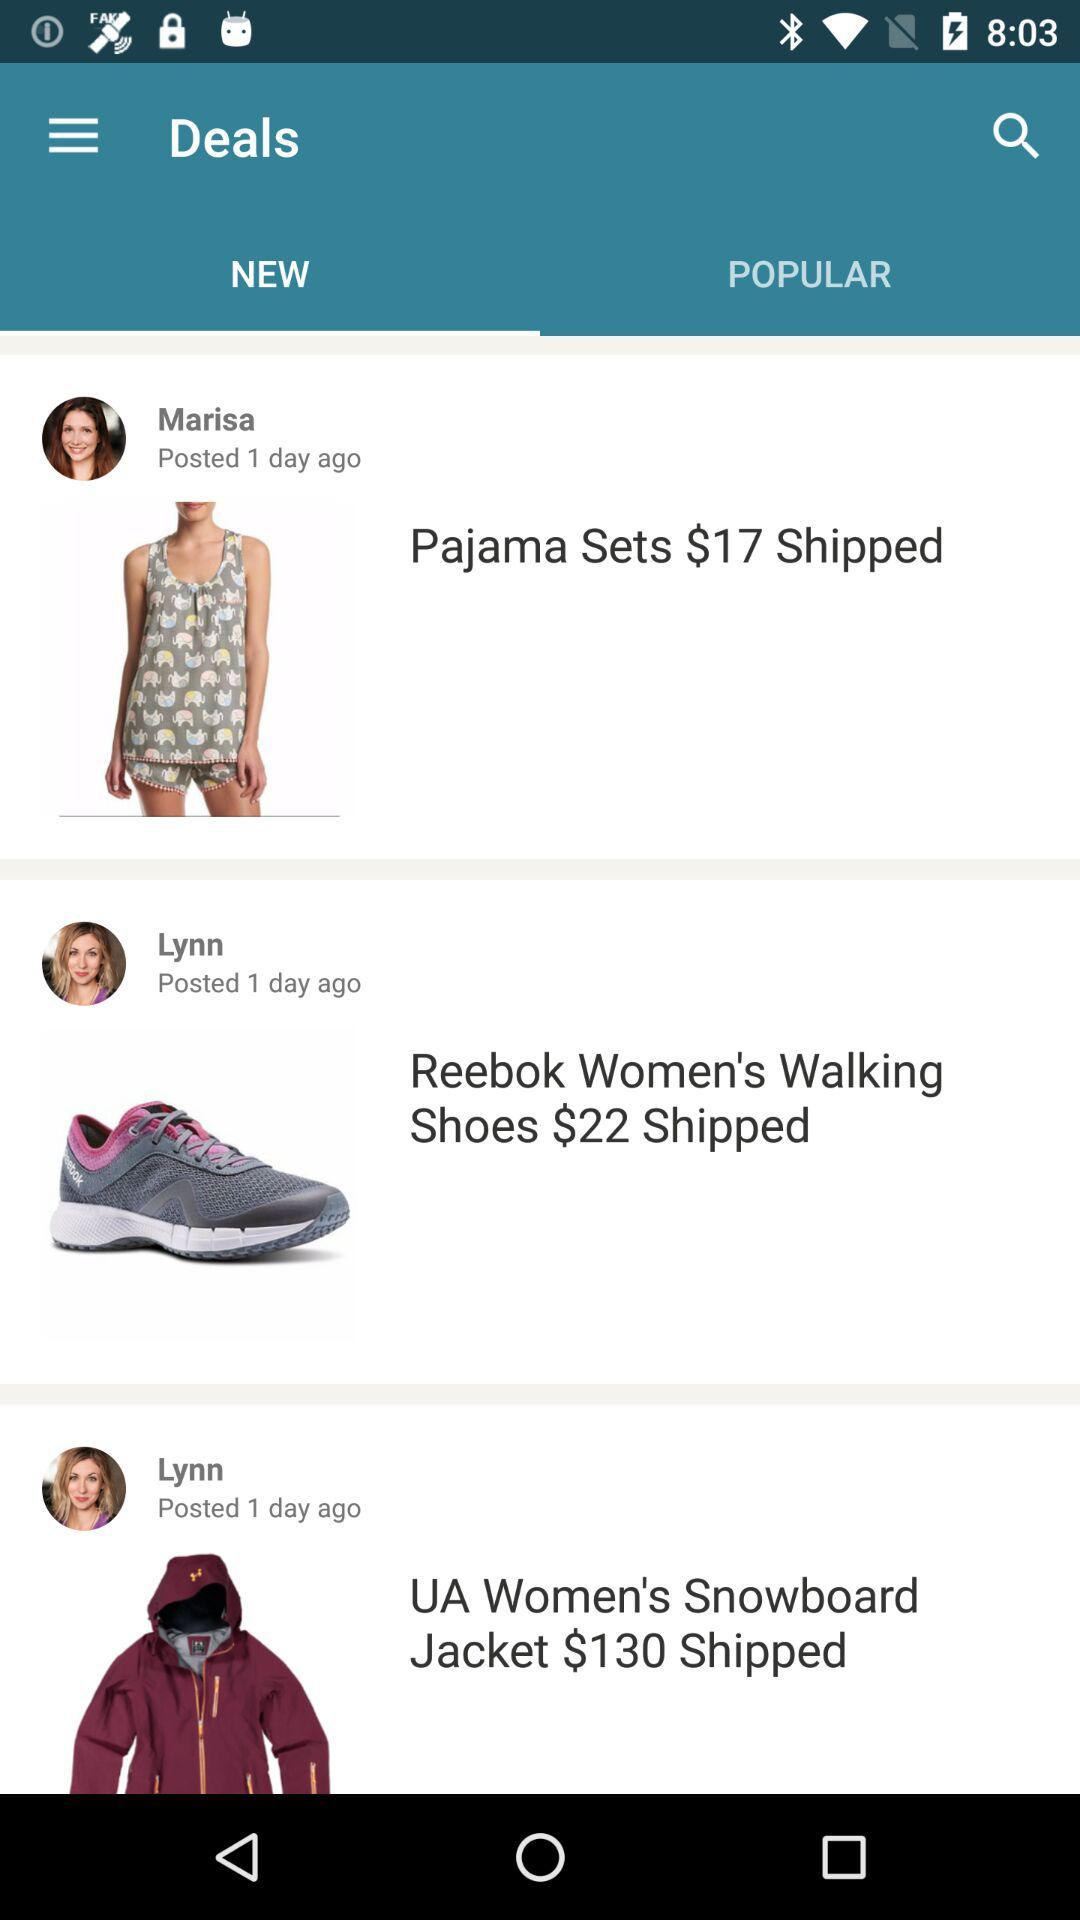What is the price of the "Reebok Women's Walking Shoes"? The price is $22. 